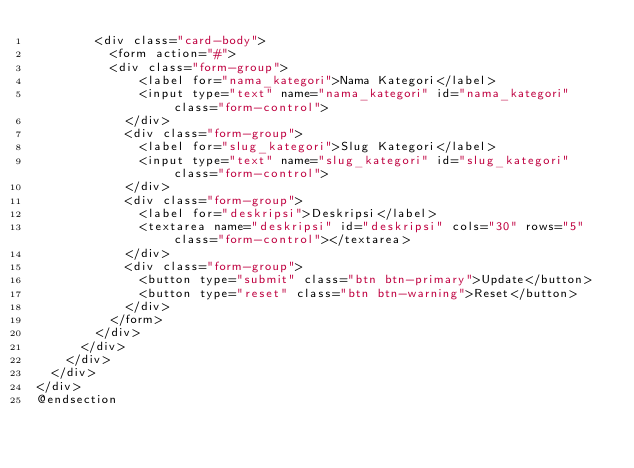<code> <loc_0><loc_0><loc_500><loc_500><_PHP_>        <div class="card-body">
          <form action="#">
          <div class="form-group">
              <label for="nama_kategori">Nama Kategori</label>
              <input type="text" name="nama_kategori" id="nama_kategori" class="form-control">
            </div>
            <div class="form-group">
              <label for="slug_kategori">Slug Kategori</label>
              <input type="text" name="slug_kategori" id="slug_kategori" class="form-control">
            </div>
            <div class="form-group">
              <label for="deskripsi">Deskripsi</label>
              <textarea name="deskripsi" id="deskripsi" cols="30" rows="5" class="form-control"></textarea>
            </div>
            <div class="form-group">
              <button type="submit" class="btn btn-primary">Update</button>
              <button type="reset" class="btn btn-warning">Reset</button>
            </div>
          </form>
        </div>
      </div>
    </div>
  </div>
</div>
@endsection</code> 